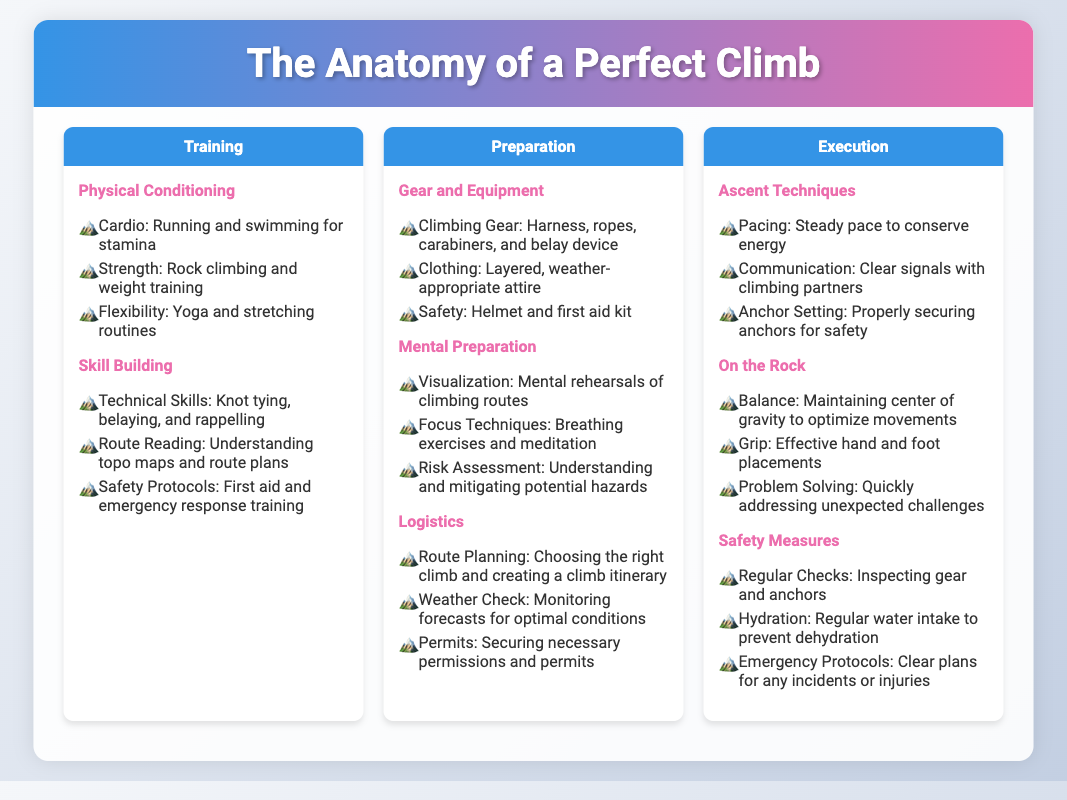what is the first aspect of Training? The first aspect of Training is Physical Conditioning, which focuses on building endurance and strength.
Answer: Physical Conditioning which climbing skill involves understanding route plans? This skill is referred to as Route Reading, which helps climbers understand the terrain and plan their ascent.
Answer: Route Reading what gear is crucial for climbing safety? A helmet is crucial for climbing safety, along with other essential equipment listed.
Answer: Helmet what mental technique is recommended before climbing? Visualization is recommended as a mental technique to mentally rehearse climbing routes before tackling them.
Answer: Visualization how many aspects are covered in the Execution section? The Execution section covers three aspects, including Ascent Techniques, On the Rock, and Safety Measures.
Answer: Three which aspect of Preparation involves checking the weather? The aspect of Preparation that involves checking the weather is Weather Check, which helps climbers prepare for optimal conditions.
Answer: Weather Check what is the main purpose of pacing during a climb? The main purpose of pacing is to conserve energy during the ascent by maintaining a steady pace.
Answer: Conserve energy what type of training helps improve flexibility? Yoga and stretching routines help improve flexibility as part of physical conditioning training.
Answer: Yoga and stretching routines which section discusses the gear needed for climbing? The section that discusses the gear needed for climbing is Preparation, specifically the Gear and Equipment subsection.
Answer: Preparation 